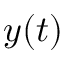<formula> <loc_0><loc_0><loc_500><loc_500>y ( t )</formula> 